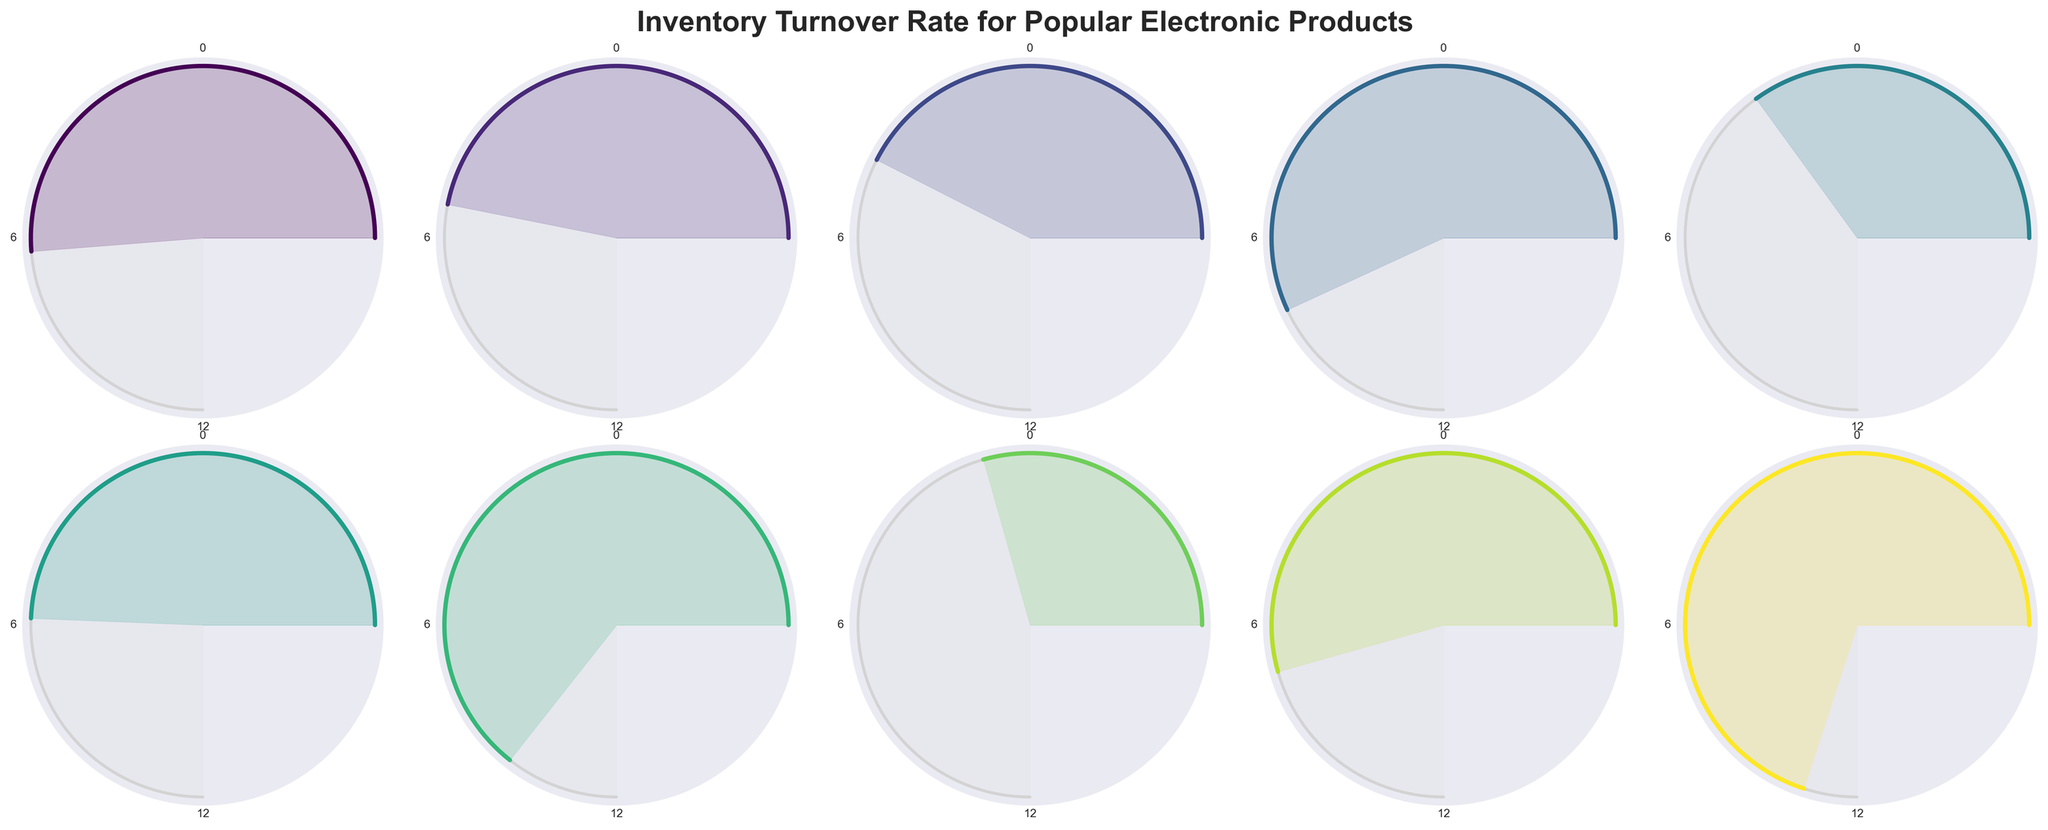what is the inventory turnover rate for the Apple iPhone 13? The Apple iPhone 13 gauge displays 8.2, indicating its inventory turnover rate.
Answer: 8.2 Which product has the highest inventory turnover rate? The gauge for the Amazon Echo Dot is filled the most, indicating it has the highest turnover rate of 11.2.
Answer: Amazon Echo Dot Compare the inventory turnover rates of Fitbit Charge 5 and Dell XPS 15 Laptop. Which is higher and by how much? Fitbit Charge 5 has a turnover rate of 8.7, while Dell XPS 15 Laptop has 5.6. Subtracting the two, 8.7 - 5.6 = 3.1.
Answer: Fitbit Charge 5 is higher by 3.1 What are the average turnover rates of the Apple products listed? Apple iPhone 13 has 8.2 and Apple AirPods Pro has 10.3. The sum is 8.2 + 10.3 = 18.5. Divide by 2 to get 18.5 / 2 = 9.25.
Answer: 9.25 How many products have a turnover rate higher than 9? Apple AirPods Pro (10.3), Nintendo Switch (9.1), and Amazon Echo Dot (11.2) all have rates higher than 9.
Answer: 3 What is the total turnover rate of all the products combined? Summing the turnover rates: 8.2 + 7.5 + 6.8 + 9.1 + 5.6 + 7.9 + 10.3 + 4.7 + 8.7 + 11.2 = 80.
Answer: 80 Which product has the lowest inventory turnover rate? The gauge for the LG OLED C1 TV is filled the least, indicating it has the lowest turnover rate of 4.7.
Answer: LG OLED C1 TV 